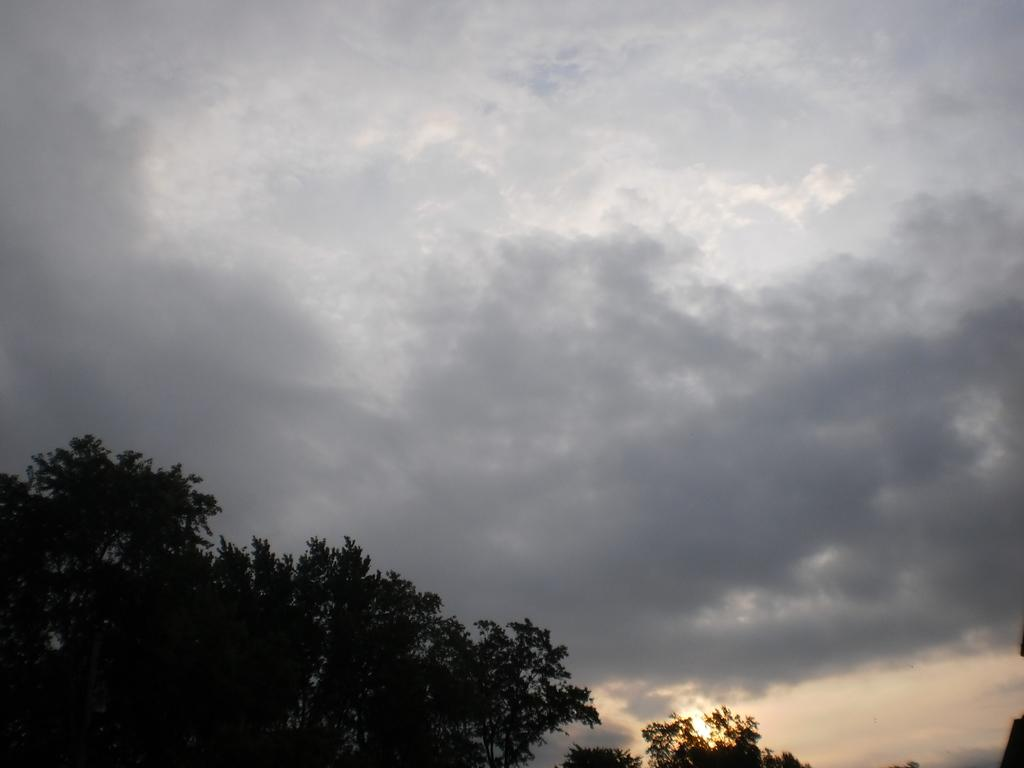What type of vegetation is located at the bottom left of the image? There are trees at the bottom left of the image. What part of the natural environment is visible at the top of the image? The sky is visible at the top of the image. How many giants can be seen making a decision in the image? There are no giants or decisions depicted in the image; it features trees and sky. What type of humor is present in the image? There is no humor present in the image; it is a simple depiction of trees and sky. 